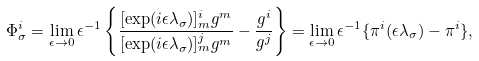Convert formula to latex. <formula><loc_0><loc_0><loc_500><loc_500>\Phi _ { \sigma } ^ { i } = \lim _ { \epsilon \to 0 } \epsilon ^ { - 1 } \left \{ \frac { [ \exp ( i \epsilon \lambda _ { \sigma } ) ] _ { m } ^ { i } g ^ { m } } { [ \exp ( i \epsilon \lambda _ { \sigma } ) ] _ { m } ^ { j } g ^ { m } } - \frac { g ^ { i } } { g ^ { j } } \right \} = \lim _ { \epsilon \to 0 } \epsilon ^ { - 1 } \{ \pi ^ { i } ( \epsilon \lambda _ { \sigma } ) - \pi ^ { i } \} ,</formula> 